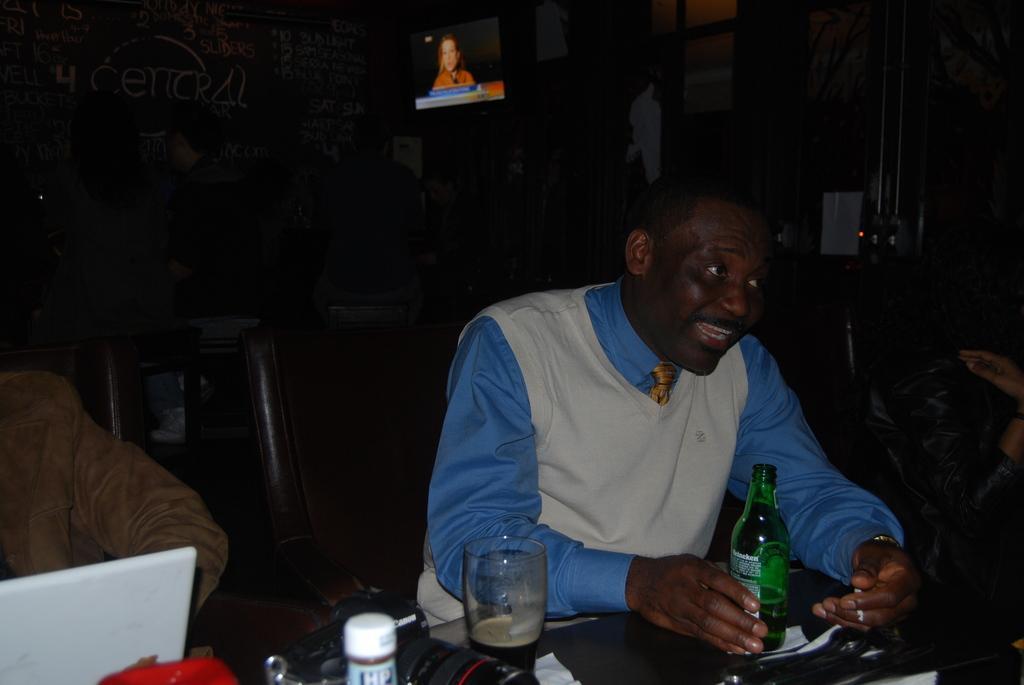How would you summarize this image in a sentence or two? In this picture we can see two people sitting on chairs in front of a table, table consists of one bottle of alcohol and there is a glass of drink, we can also see a digital camera behind the glass, in the background we can see a television. 